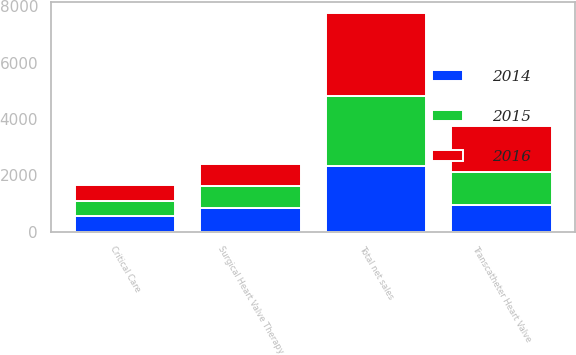<chart> <loc_0><loc_0><loc_500><loc_500><stacked_bar_chart><ecel><fcel>Transcatheter Heart Valve<fcel>Surgical Heart Valve Therapy<fcel>Critical Care<fcel>Total net sales<nl><fcel>2016<fcel>1628.5<fcel>774.9<fcel>560.3<fcel>2963.7<nl><fcel>2015<fcel>1180.3<fcel>785<fcel>528.4<fcel>2493.7<nl><fcel>2014<fcel>943.6<fcel>826.1<fcel>553.2<fcel>2322.9<nl></chart> 